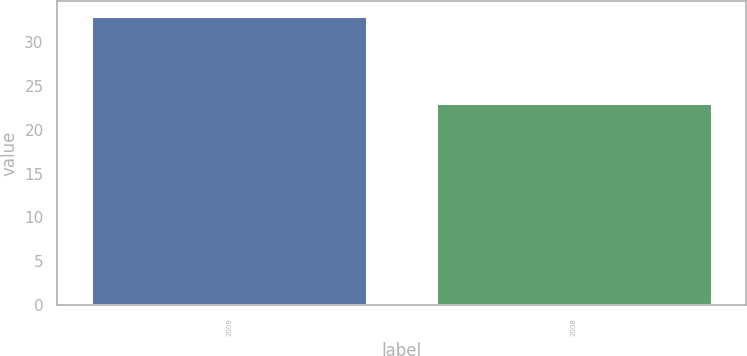Convert chart. <chart><loc_0><loc_0><loc_500><loc_500><bar_chart><fcel>2009<fcel>2008<nl><fcel>33<fcel>23<nl></chart> 